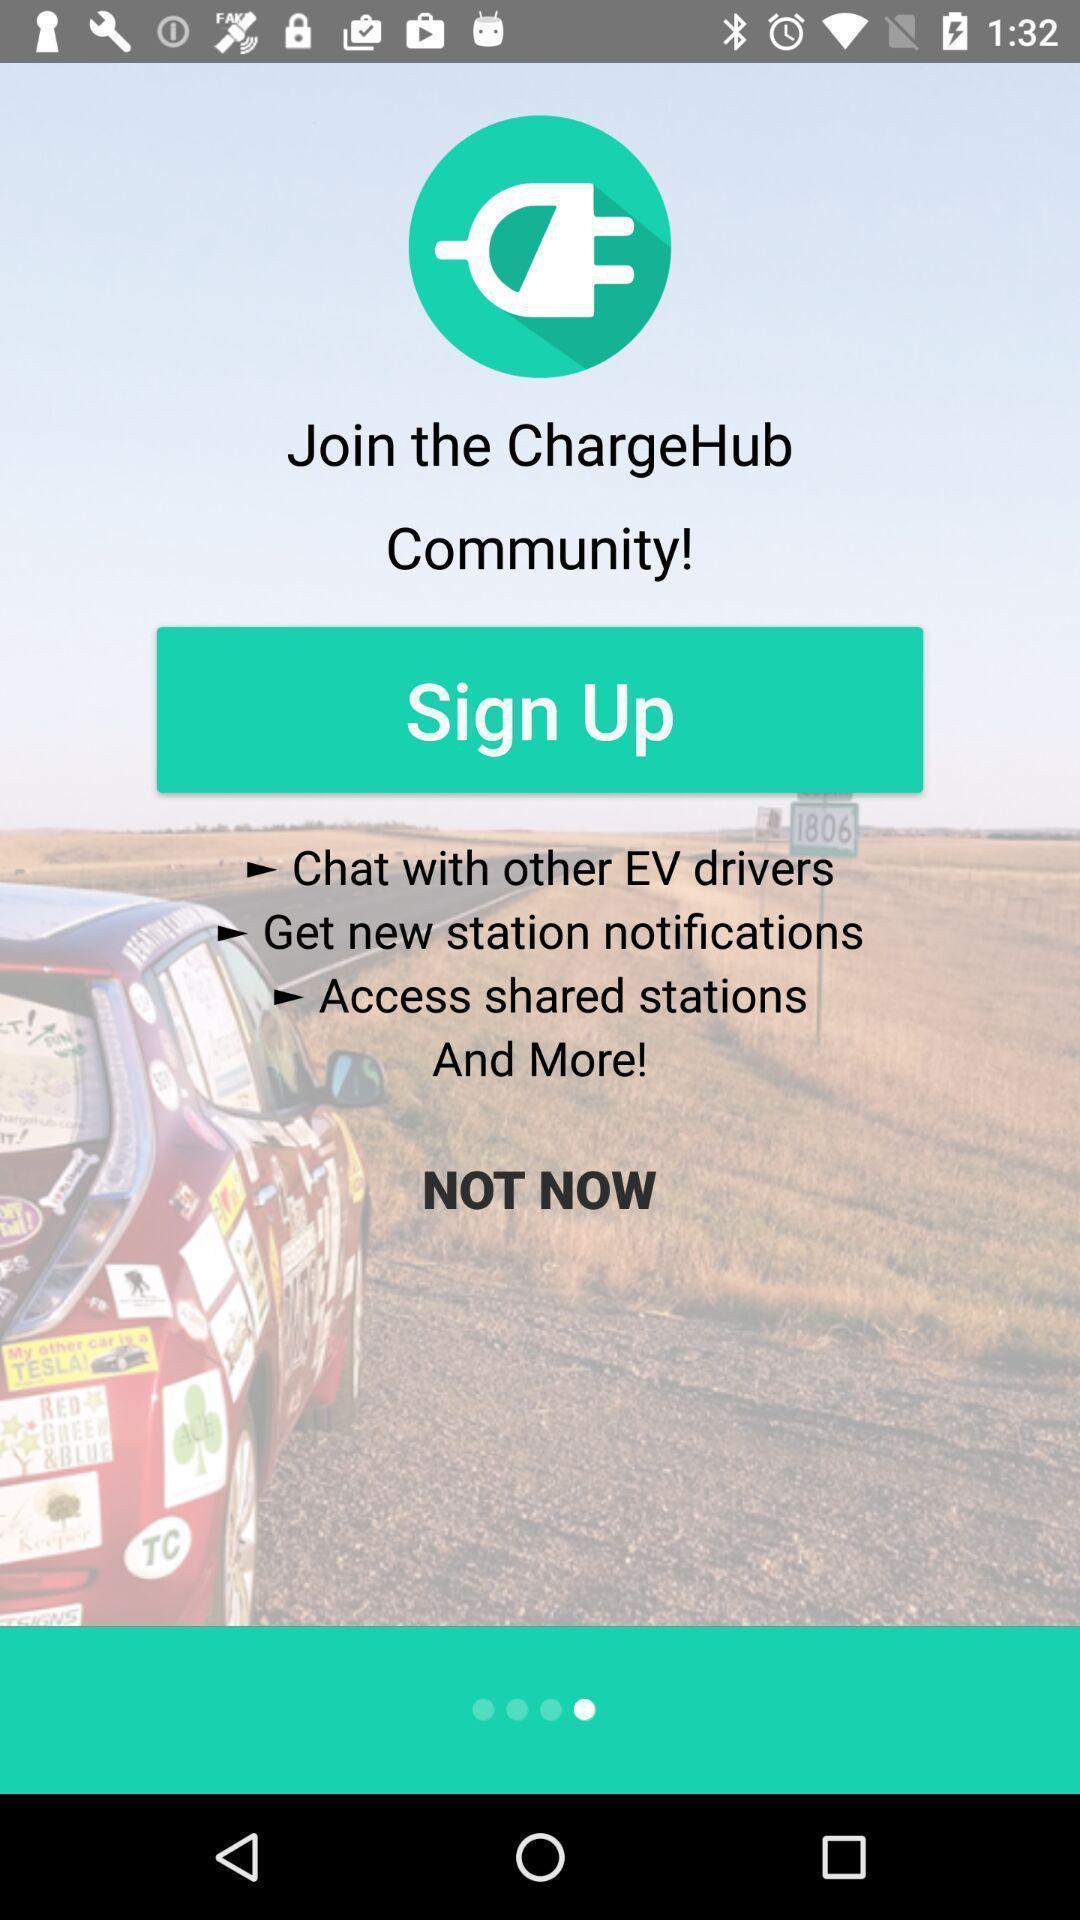Summarize the main components in this picture. Sign up page of a charging stations app. 